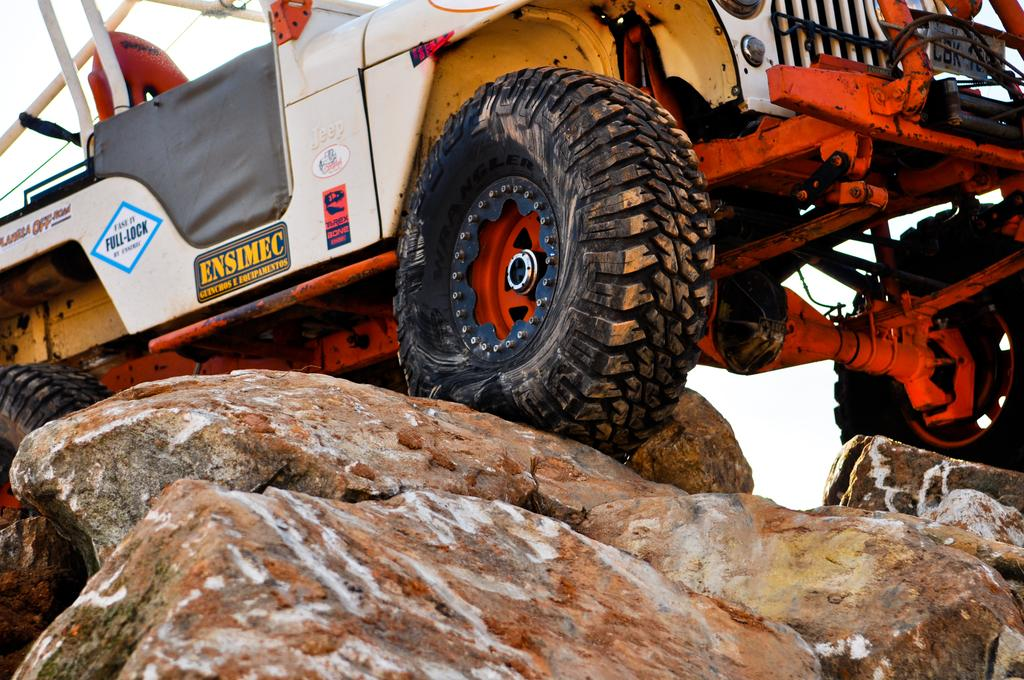What is the main subject of the image? There is a vehicle in the image. Where is the vehicle located? The vehicle is on rocks. What type of vehicle is it? The vehicle is an open-top vehicle. What is the profit margin of the vehicle in the image? There is no information about the profit margin of the vehicle in the image, as it is not relevant to the visual content. 